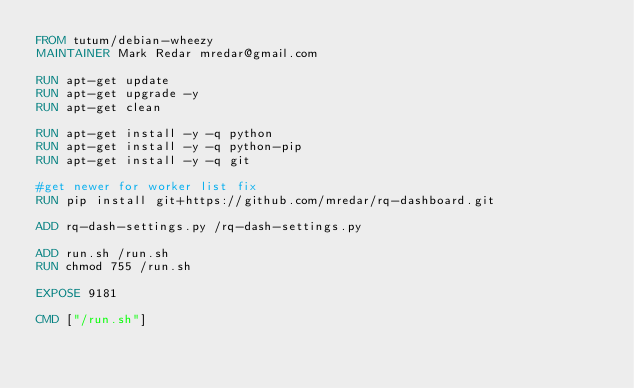<code> <loc_0><loc_0><loc_500><loc_500><_Dockerfile_>FROM tutum/debian-wheezy
MAINTAINER Mark Redar mredar@gmail.com

RUN apt-get update
RUN apt-get upgrade -y
RUN apt-get clean

RUN apt-get install -y -q python
RUN apt-get install -y -q python-pip
RUN apt-get install -y -q git

#get newer for worker list fix
RUN pip install git+https://github.com/mredar/rq-dashboard.git

ADD rq-dash-settings.py /rq-dash-settings.py

ADD run.sh /run.sh
RUN chmod 755 /run.sh

EXPOSE 9181

CMD ["/run.sh"]
</code> 